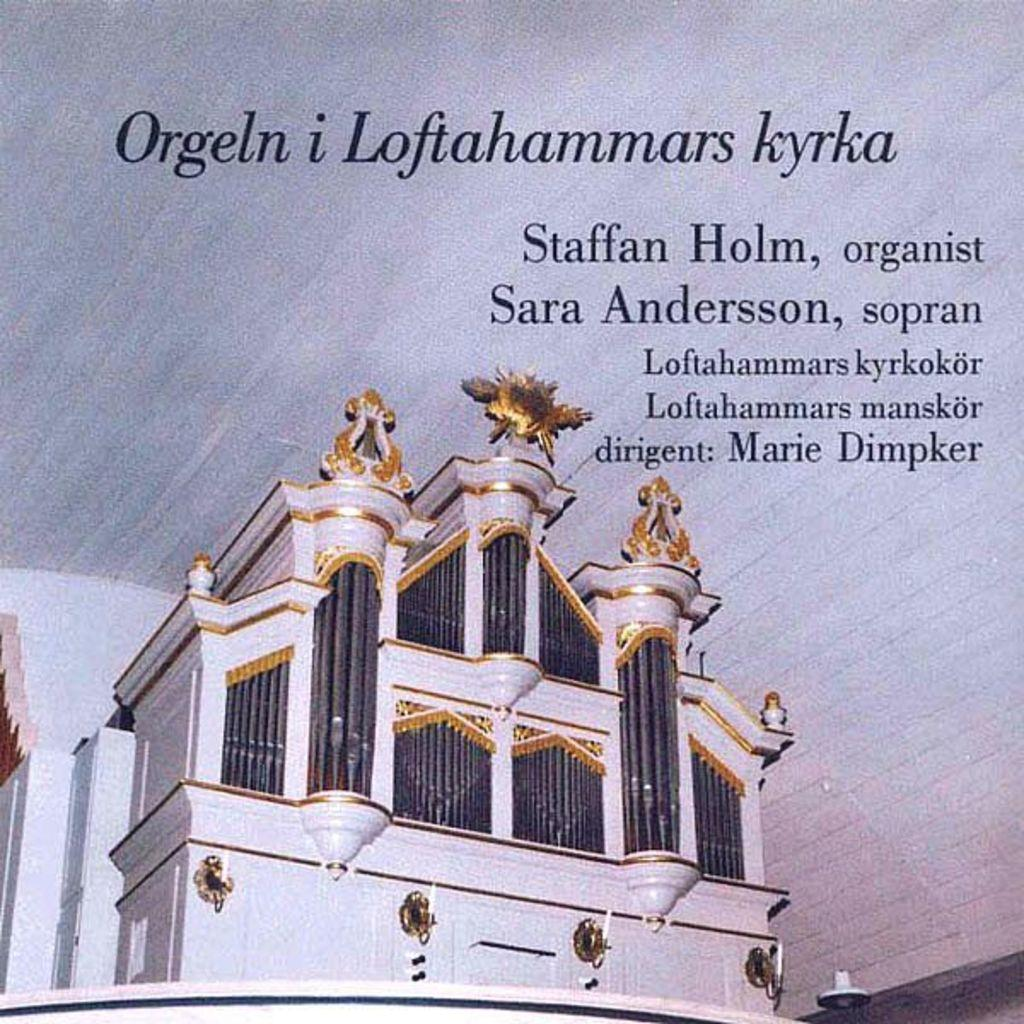What is the main subject of the image? The main subject of the image is a photo of a building. Can you describe the colors of the building in the image? The building is white and golden in color. How is the text in the image presented? The text in the image is printed. How many chickens can be seen in the image? There are no chickens present in the image. What is the weather like in the image, considering the presence of the sun and snow? There is no reference to the sun or snow in the image, as it features a photo of a building with printed text. 